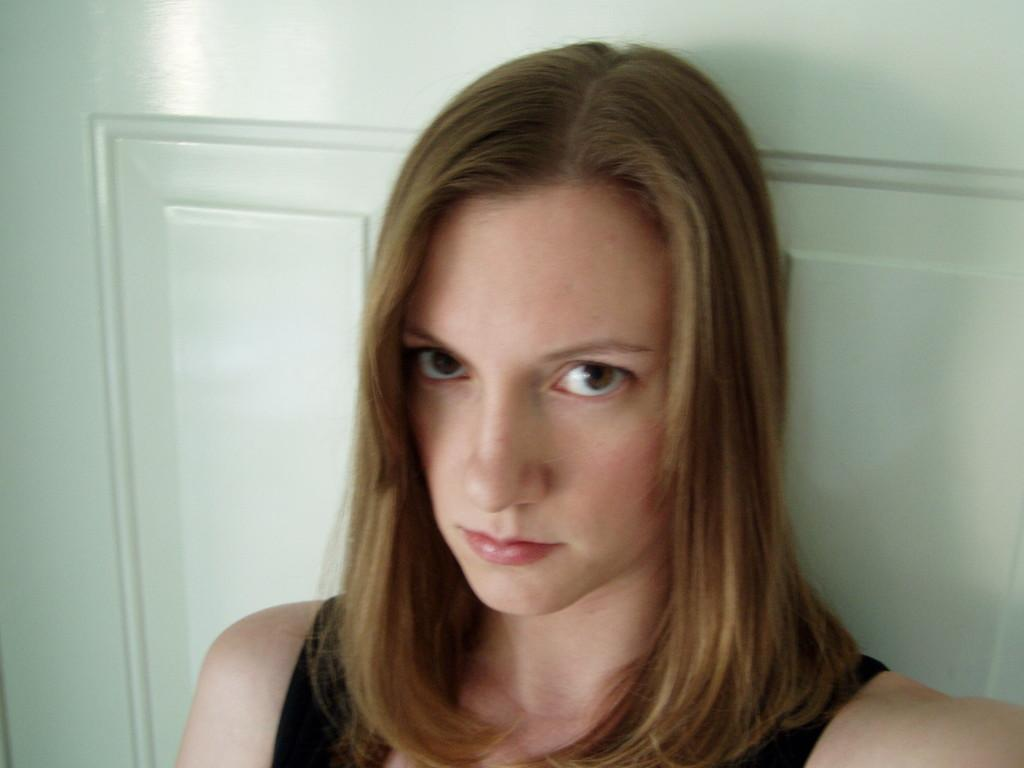Who is the main subject in the image? There is a woman in the center of the image. What can be seen in the background of the image? There is a door in the background of the image. What type of discussion is taking place in the park in the image? There is no park or discussion present in the image; it only features a woman and a door in the background. 